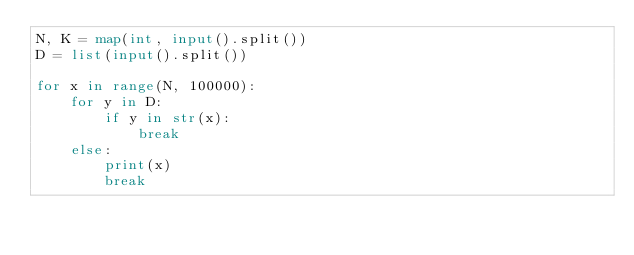<code> <loc_0><loc_0><loc_500><loc_500><_Python_>N, K = map(int, input().split())
D = list(input().split())

for x in range(N, 100000):
    for y in D:
        if y in str(x):
            break
    else:
        print(x)
        break

</code> 